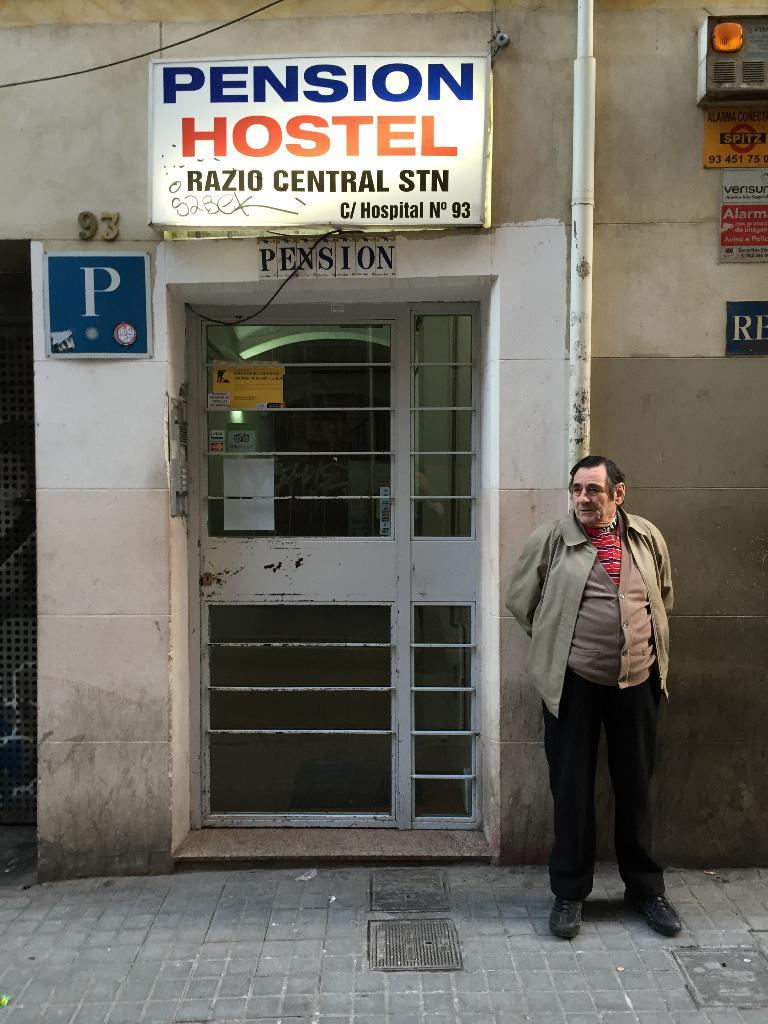Who is present in the image? There is a man in the image. What is the man doing in the image? The man is standing in front of a door. What can be seen behind the man? There is a pipe visible behind the man. What is on the wall in the image? There is a hoarding on the wall and sign boards on the wall. How long does it take for the giants to walk past the door in the image? There are no giants present in the image, so it is not possible to determine how long it would take for them to walk past the door. 